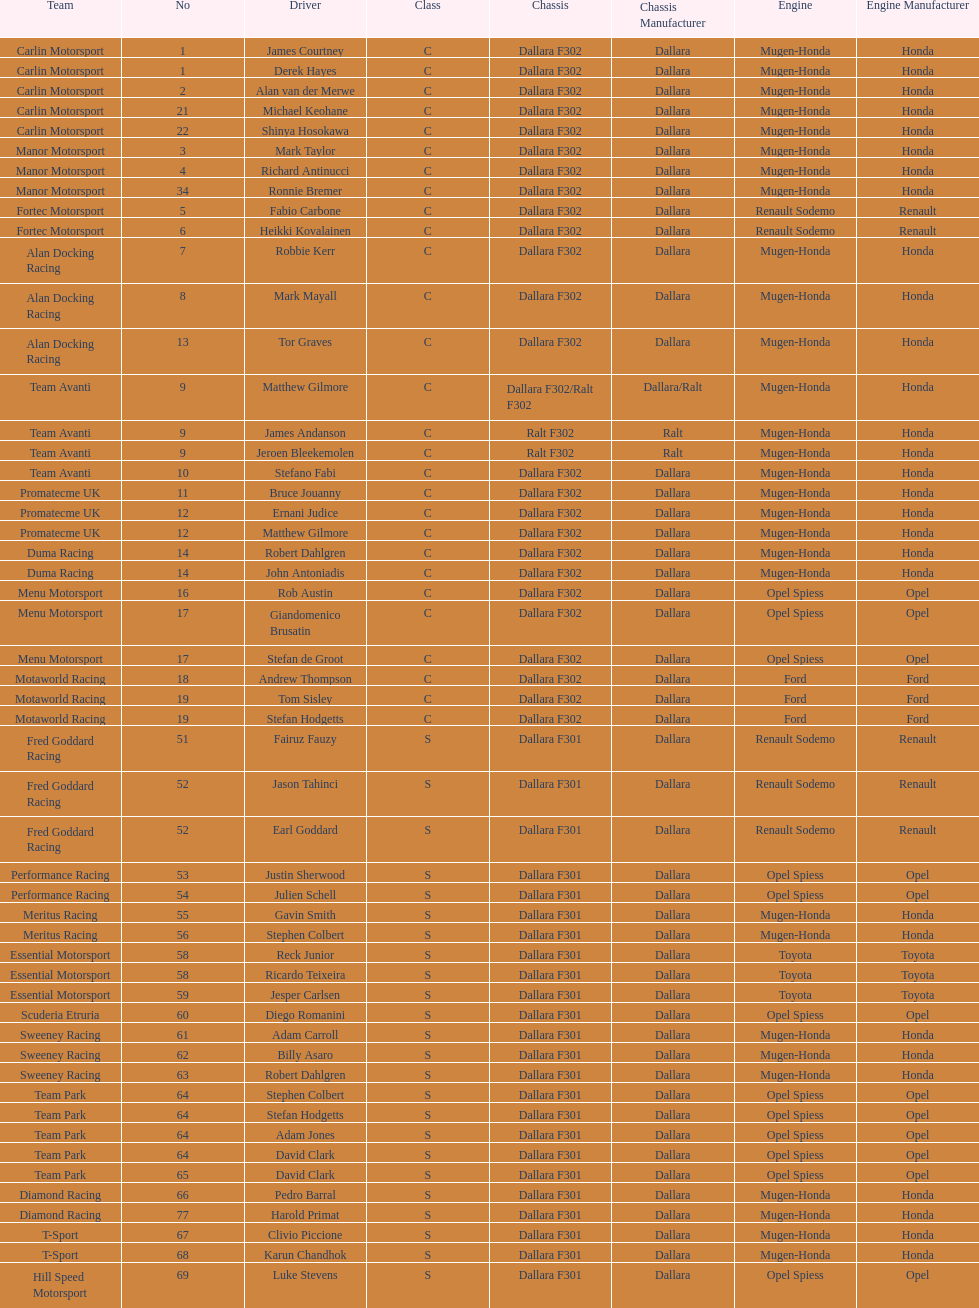Who had more drivers, team avanti or motaworld racing? Team Avanti. Can you give me this table as a dict? {'header': ['Team', 'No', 'Driver', 'Class', 'Chassis', 'Chassis Manufacturer', 'Engine', 'Engine Manufacturer'], 'rows': [['Carlin Motorsport', '1', 'James Courtney', 'C', 'Dallara F302', 'Dallara', 'Mugen-Honda', 'Honda'], ['Carlin Motorsport', '1', 'Derek Hayes', 'C', 'Dallara F302', 'Dallara', 'Mugen-Honda', 'Honda'], ['Carlin Motorsport', '2', 'Alan van der Merwe', 'C', 'Dallara F302', 'Dallara', 'Mugen-Honda', 'Honda'], ['Carlin Motorsport', '21', 'Michael Keohane', 'C', 'Dallara F302', 'Dallara', 'Mugen-Honda', 'Honda'], ['Carlin Motorsport', '22', 'Shinya Hosokawa', 'C', 'Dallara F302', 'Dallara', 'Mugen-Honda', 'Honda'], ['Manor Motorsport', '3', 'Mark Taylor', 'C', 'Dallara F302', 'Dallara', 'Mugen-Honda', 'Honda'], ['Manor Motorsport', '4', 'Richard Antinucci', 'C', 'Dallara F302', 'Dallara', 'Mugen-Honda', 'Honda'], ['Manor Motorsport', '34', 'Ronnie Bremer', 'C', 'Dallara F302', 'Dallara', 'Mugen-Honda', 'Honda'], ['Fortec Motorsport', '5', 'Fabio Carbone', 'C', 'Dallara F302', 'Dallara', 'Renault Sodemo', 'Renault'], ['Fortec Motorsport', '6', 'Heikki Kovalainen', 'C', 'Dallara F302', 'Dallara', 'Renault Sodemo', 'Renault'], ['Alan Docking Racing', '7', 'Robbie Kerr', 'C', 'Dallara F302', 'Dallara', 'Mugen-Honda', 'Honda'], ['Alan Docking Racing', '8', 'Mark Mayall', 'C', 'Dallara F302', 'Dallara', 'Mugen-Honda', 'Honda'], ['Alan Docking Racing', '13', 'Tor Graves', 'C', 'Dallara F302', 'Dallara', 'Mugen-Honda', 'Honda'], ['Team Avanti', '9', 'Matthew Gilmore', 'C', 'Dallara F302/Ralt F302', 'Dallara/Ralt', 'Mugen-Honda', 'Honda'], ['Team Avanti', '9', 'James Andanson', 'C', 'Ralt F302', 'Ralt', 'Mugen-Honda', 'Honda'], ['Team Avanti', '9', 'Jeroen Bleekemolen', 'C', 'Ralt F302', 'Ralt', 'Mugen-Honda', 'Honda'], ['Team Avanti', '10', 'Stefano Fabi', 'C', 'Dallara F302', 'Dallara', 'Mugen-Honda', 'Honda'], ['Promatecme UK', '11', 'Bruce Jouanny', 'C', 'Dallara F302', 'Dallara', 'Mugen-Honda', 'Honda'], ['Promatecme UK', '12', 'Ernani Judice', 'C', 'Dallara F302', 'Dallara', 'Mugen-Honda', 'Honda'], ['Promatecme UK', '12', 'Matthew Gilmore', 'C', 'Dallara F302', 'Dallara', 'Mugen-Honda', 'Honda'], ['Duma Racing', '14', 'Robert Dahlgren', 'C', 'Dallara F302', 'Dallara', 'Mugen-Honda', 'Honda'], ['Duma Racing', '14', 'John Antoniadis', 'C', 'Dallara F302', 'Dallara', 'Mugen-Honda', 'Honda'], ['Menu Motorsport', '16', 'Rob Austin', 'C', 'Dallara F302', 'Dallara', 'Opel Spiess', 'Opel'], ['Menu Motorsport', '17', 'Giandomenico Brusatin', 'C', 'Dallara F302', 'Dallara', 'Opel Spiess', 'Opel'], ['Menu Motorsport', '17', 'Stefan de Groot', 'C', 'Dallara F302', 'Dallara', 'Opel Spiess', 'Opel'], ['Motaworld Racing', '18', 'Andrew Thompson', 'C', 'Dallara F302', 'Dallara', 'Ford', 'Ford'], ['Motaworld Racing', '19', 'Tom Sisley', 'C', 'Dallara F302', 'Dallara', 'Ford', 'Ford'], ['Motaworld Racing', '19', 'Stefan Hodgetts', 'C', 'Dallara F302', 'Dallara', 'Ford', 'Ford'], ['Fred Goddard Racing', '51', 'Fairuz Fauzy', 'S', 'Dallara F301', 'Dallara', 'Renault Sodemo', 'Renault'], ['Fred Goddard Racing', '52', 'Jason Tahinci', 'S', 'Dallara F301', 'Dallara', 'Renault Sodemo', 'Renault'], ['Fred Goddard Racing', '52', 'Earl Goddard', 'S', 'Dallara F301', 'Dallara', 'Renault Sodemo', 'Renault'], ['Performance Racing', '53', 'Justin Sherwood', 'S', 'Dallara F301', 'Dallara', 'Opel Spiess', 'Opel'], ['Performance Racing', '54', 'Julien Schell', 'S', 'Dallara F301', 'Dallara', 'Opel Spiess', 'Opel'], ['Meritus Racing', '55', 'Gavin Smith', 'S', 'Dallara F301', 'Dallara', 'Mugen-Honda', 'Honda'], ['Meritus Racing', '56', 'Stephen Colbert', 'S', 'Dallara F301', 'Dallara', 'Mugen-Honda', 'Honda'], ['Essential Motorsport', '58', 'Reck Junior', 'S', 'Dallara F301', 'Dallara', 'Toyota', 'Toyota'], ['Essential Motorsport', '58', 'Ricardo Teixeira', 'S', 'Dallara F301', 'Dallara', 'Toyota', 'Toyota'], ['Essential Motorsport', '59', 'Jesper Carlsen', 'S', 'Dallara F301', 'Dallara', 'Toyota', 'Toyota'], ['Scuderia Etruria', '60', 'Diego Romanini', 'S', 'Dallara F301', 'Dallara', 'Opel Spiess', 'Opel'], ['Sweeney Racing', '61', 'Adam Carroll', 'S', 'Dallara F301', 'Dallara', 'Mugen-Honda', 'Honda'], ['Sweeney Racing', '62', 'Billy Asaro', 'S', 'Dallara F301', 'Dallara', 'Mugen-Honda', 'Honda'], ['Sweeney Racing', '63', 'Robert Dahlgren', 'S', 'Dallara F301', 'Dallara', 'Mugen-Honda', 'Honda'], ['Team Park', '64', 'Stephen Colbert', 'S', 'Dallara F301', 'Dallara', 'Opel Spiess', 'Opel'], ['Team Park', '64', 'Stefan Hodgetts', 'S', 'Dallara F301', 'Dallara', 'Opel Spiess', 'Opel'], ['Team Park', '64', 'Adam Jones', 'S', 'Dallara F301', 'Dallara', 'Opel Spiess', 'Opel'], ['Team Park', '64', 'David Clark', 'S', 'Dallara F301', 'Dallara', 'Opel Spiess', 'Opel'], ['Team Park', '65', 'David Clark', 'S', 'Dallara F301', 'Dallara', 'Opel Spiess', 'Opel'], ['Diamond Racing', '66', 'Pedro Barral', 'S', 'Dallara F301', 'Dallara', 'Mugen-Honda', 'Honda'], ['Diamond Racing', '77', 'Harold Primat', 'S', 'Dallara F301', 'Dallara', 'Mugen-Honda', 'Honda'], ['T-Sport', '67', 'Clivio Piccione', 'S', 'Dallara F301', 'Dallara', 'Mugen-Honda', 'Honda'], ['T-Sport', '68', 'Karun Chandhok', 'S', 'Dallara F301', 'Dallara', 'Mugen-Honda', 'Honda'], ['Hill Speed Motorsport', '69', 'Luke Stevens', 'S', 'Dallara F301', 'Dallara', 'Opel Spiess', 'Opel']]} 